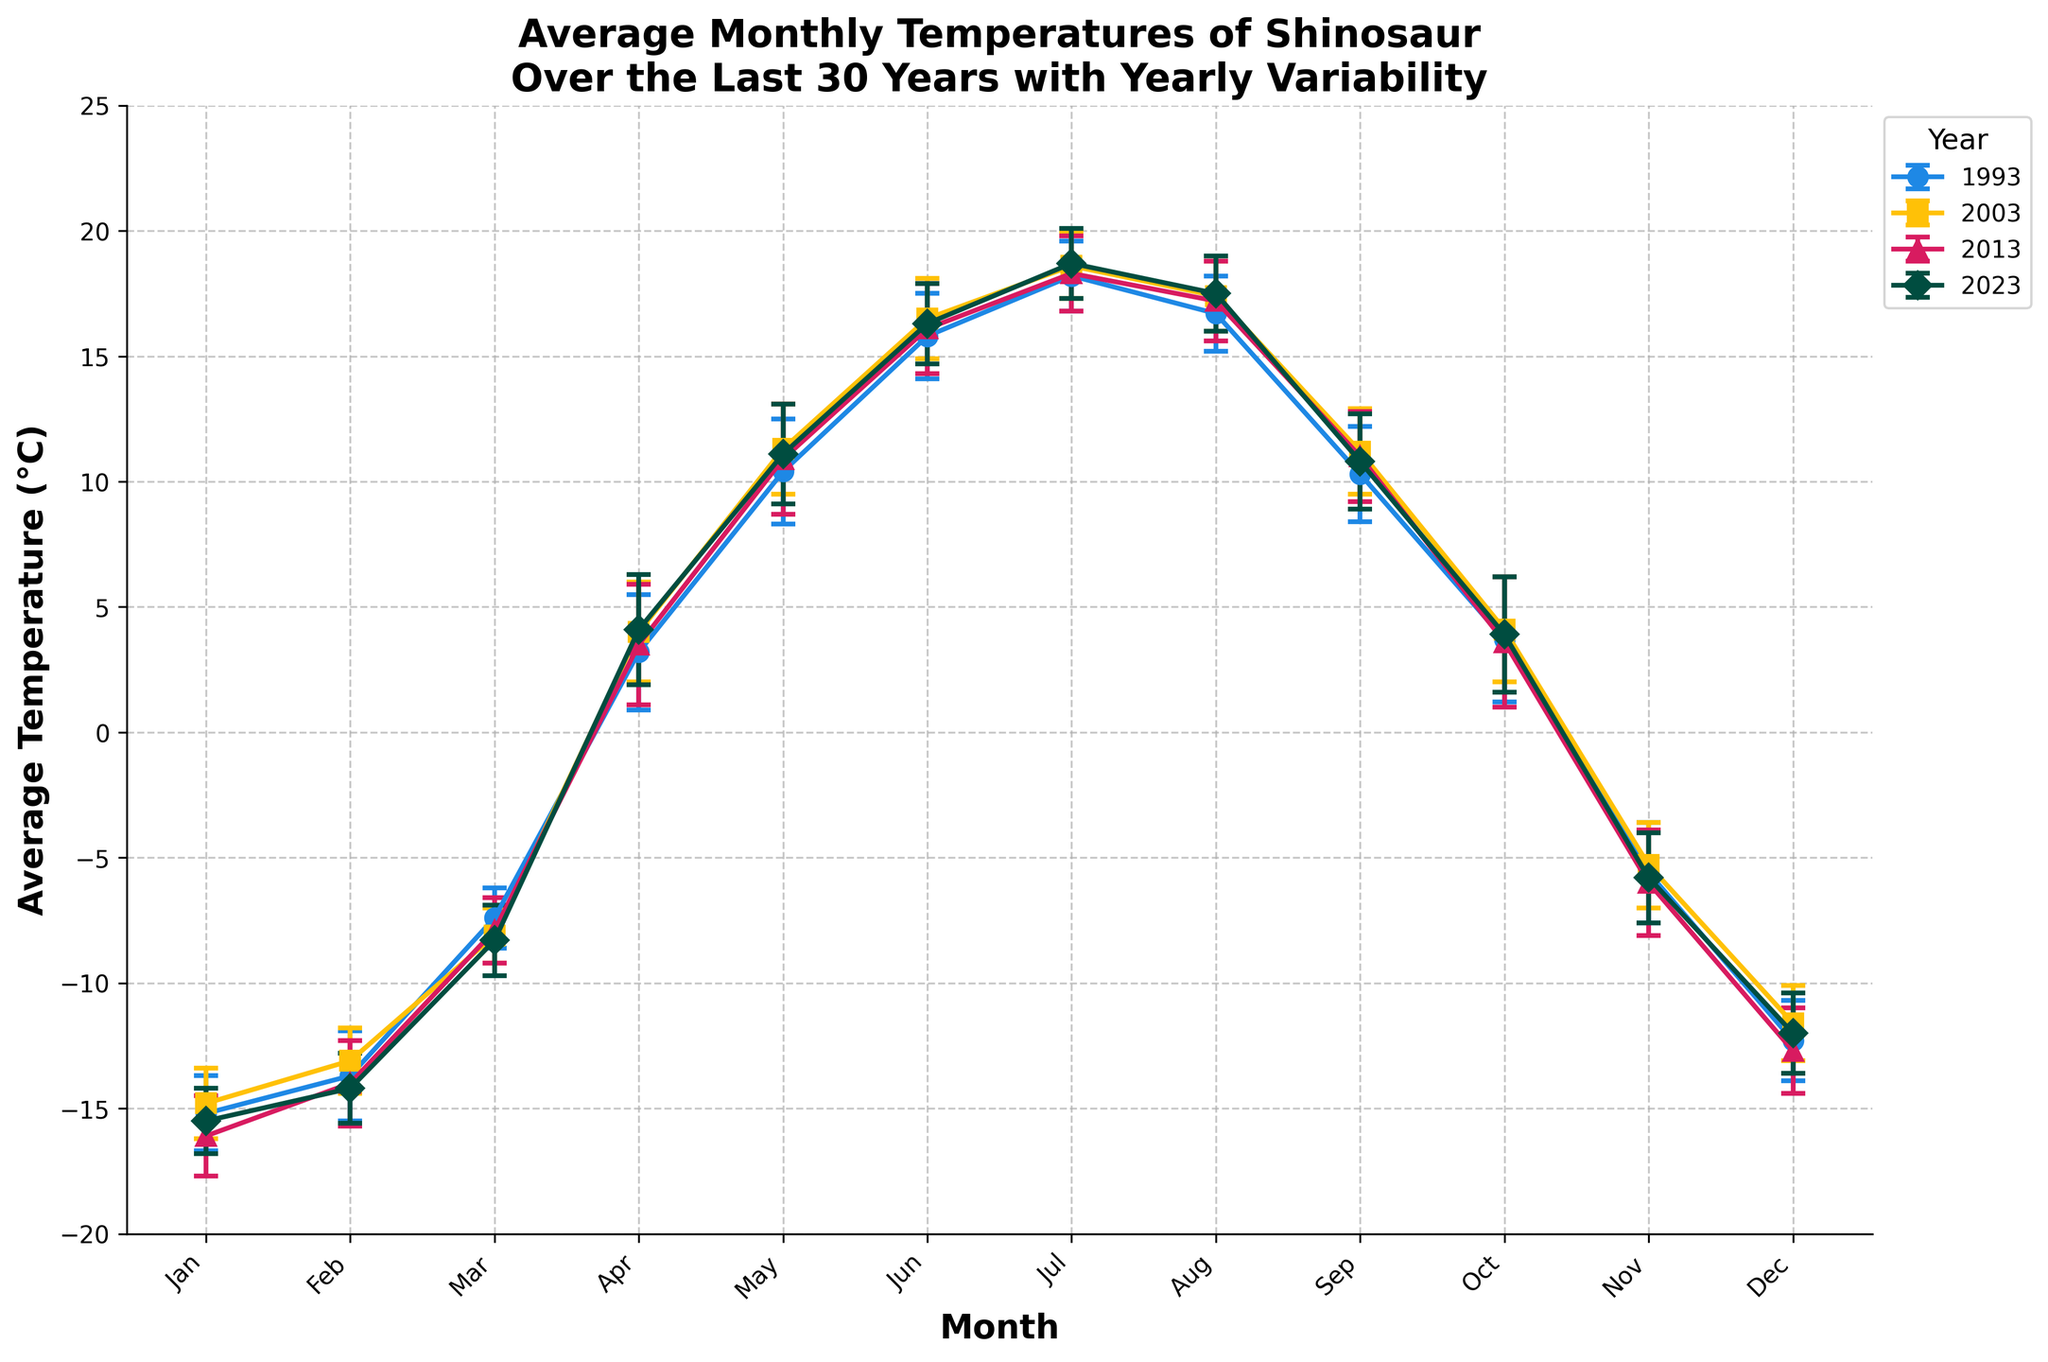What is the title of the plot? The title can be found at the top of the plot. It reads "Average Monthly Temperatures of Shinosaur Over the Last 30 Years with Yearly Variability".
Answer: Average Monthly Temperatures of Shinosaur Over the Last 30 Years with Yearly Variability How many years are represented in the plot? By counting the number of unique lines in the legend, we can see there are data points for four different years.
Answer: 4 Which month has the highest average temperature in 2023? By looking at the orange line representing the 2023 data points, the highest point is in July.
Answer: July What is the average temperature in January 1993? Refer to the blue line representing 1993; in January, the average temperature is at -15.2°C.
Answer: -15.2°C Which year had the most consistent temperatures (least variability) in July? By comparing the error bars (variability) for July, the green 2003 line has the smallest error bars.
Answer: 2003 Compare the average temperatures of April and October in 2013. In 2013, the average temperature in April is 3.5°C and in October it is 3.6°C. April's temperature is slightly less than October's temperature.
Answer: October is slightly warmer What is the general trend of average temperatures from January to December over the years? The figure shows that the temperatures increase from January, peak in July, and then decrease again towards December, indicating a seasonal pattern.
Answer: Increase, peak in July, then decrease In which month and year did temperatures change most drastically from the previous month? Identify the steepest incline or decline in the curves. Between March and April in 1993, temperature rises from -7.4°C to 3.2°C, a 10.6°C increase.
Answer: April 1993 What are the error bars representing in this plot? The error bars indicate the yearly variability in the average temperatures, showing the possible range of values around the average.
Answer: Yearly variability 